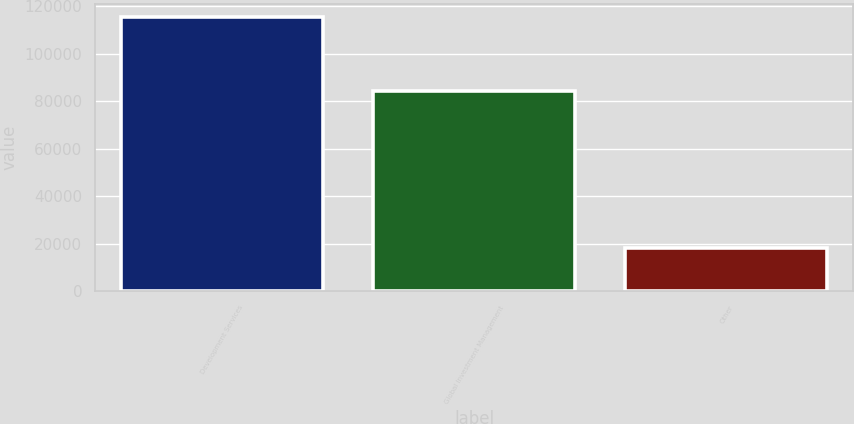Convert chart. <chart><loc_0><loc_0><loc_500><loc_500><bar_chart><fcel>Development Services<fcel>Global Investment Management<fcel>Other<nl><fcel>115326<fcel>84534<fcel>18083<nl></chart> 